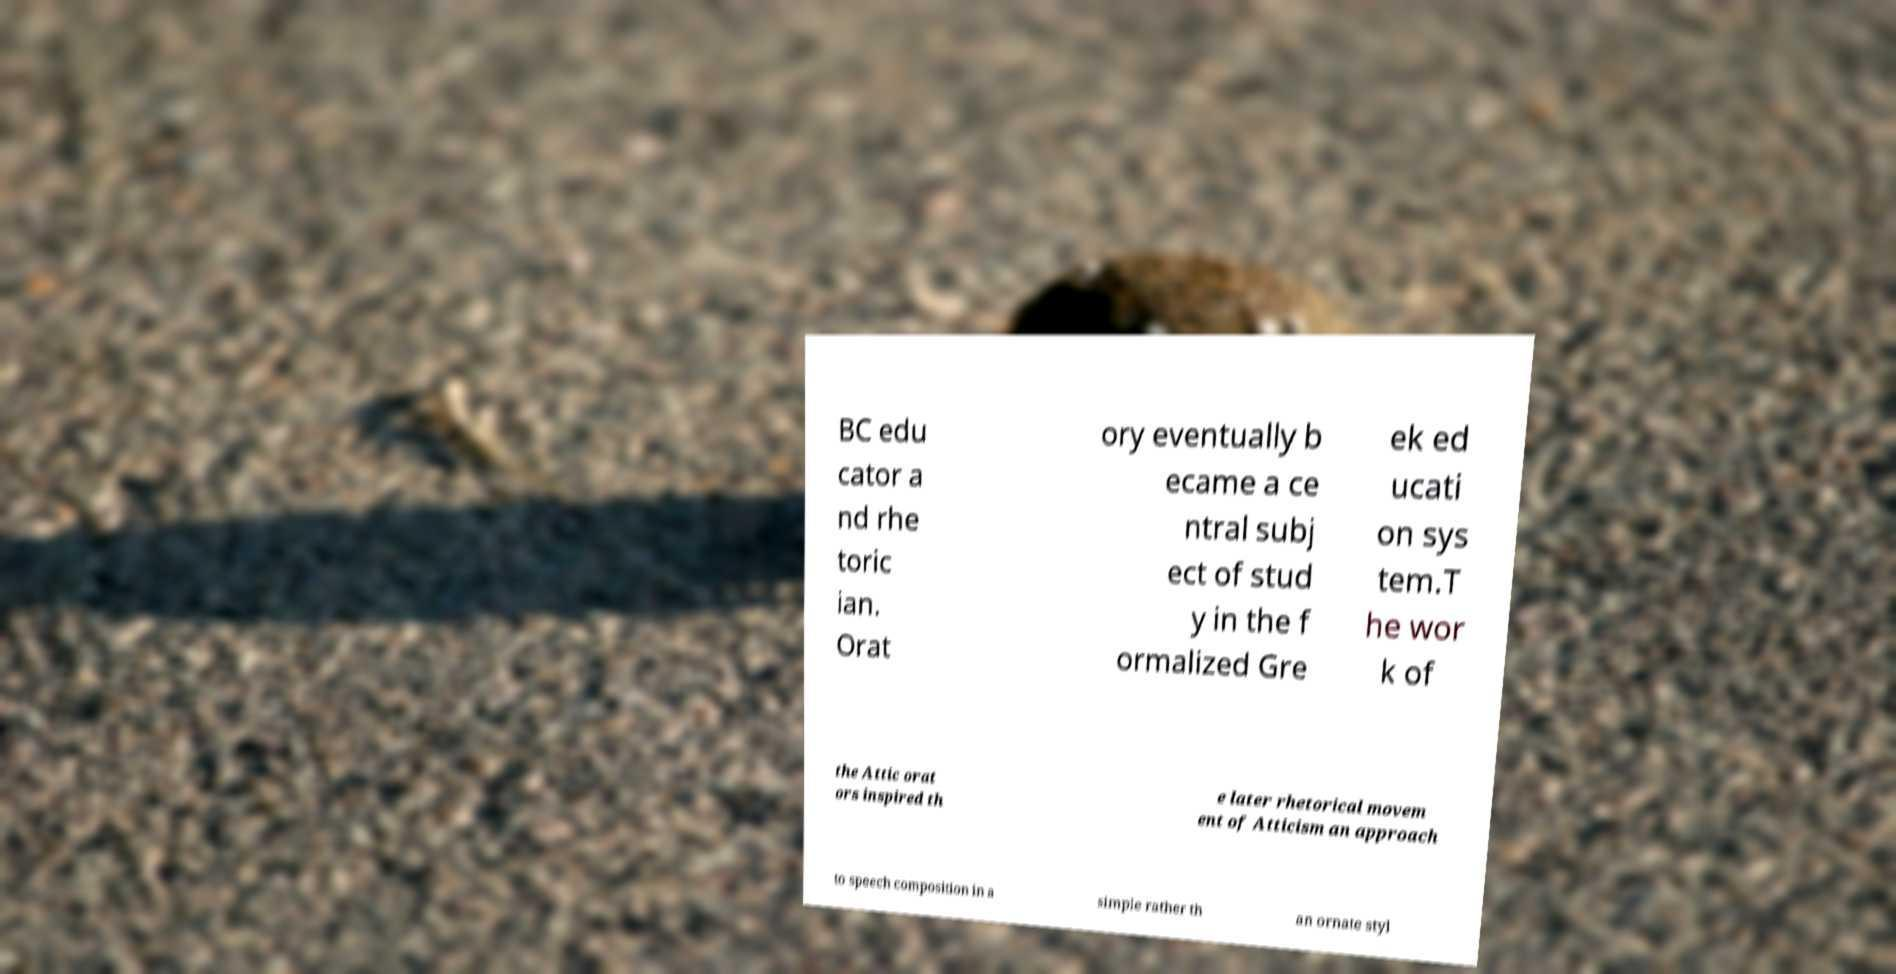Please identify and transcribe the text found in this image. BC edu cator a nd rhe toric ian. Orat ory eventually b ecame a ce ntral subj ect of stud y in the f ormalized Gre ek ed ucati on sys tem.T he wor k of the Attic orat ors inspired th e later rhetorical movem ent of Atticism an approach to speech composition in a simple rather th an ornate styl 